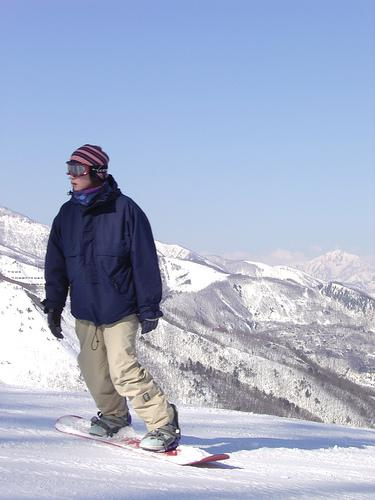Question: what is the person doing?
Choices:
A. Skating.
B. Sledding.
C. Snowboarding.
D. Skiing.
Answer with the letter. Answer: C Question: what color are the pants?
Choices:
A. Black.
B. White.
C. Tan.
D. Blue.
Answer with the letter. Answer: C 